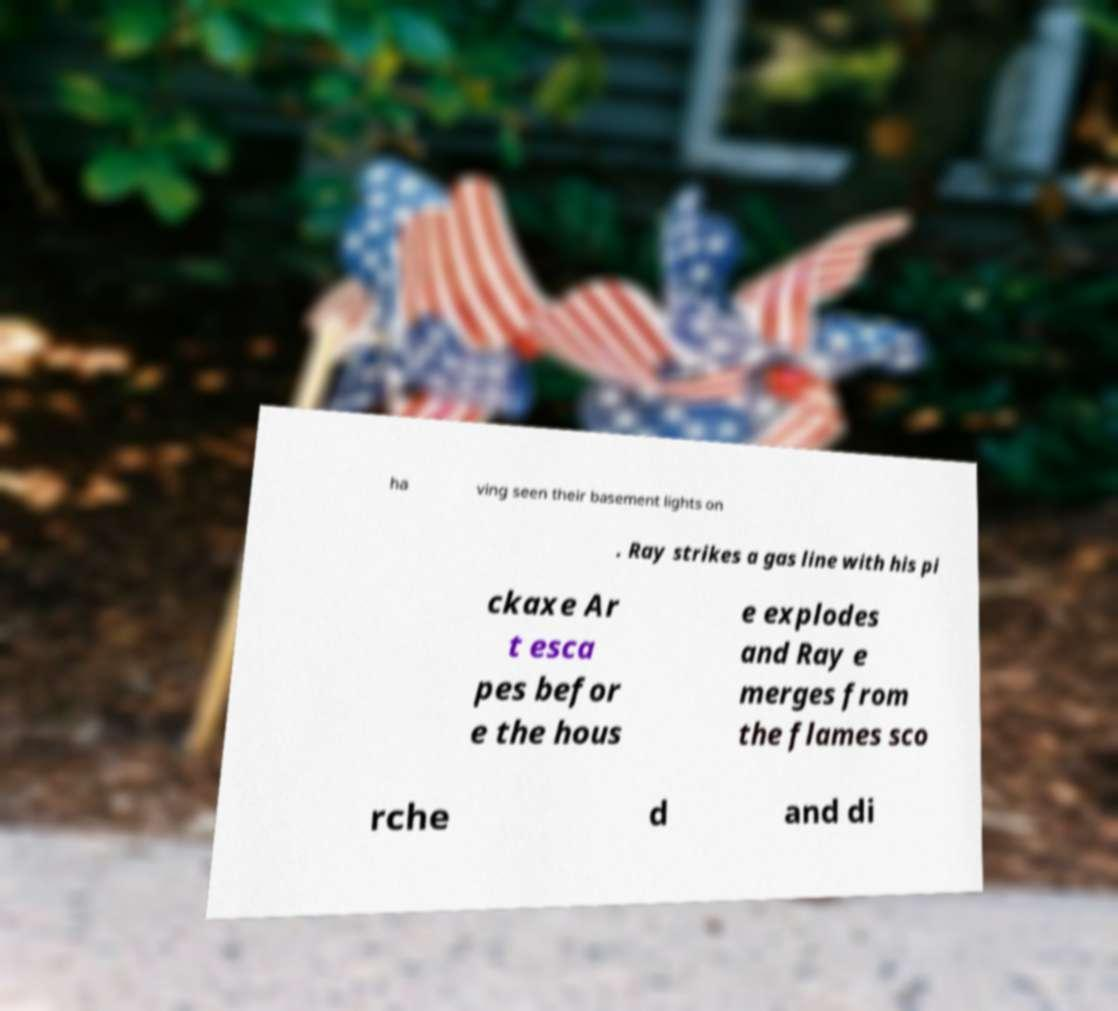Can you accurately transcribe the text from the provided image for me? ha ving seen their basement lights on . Ray strikes a gas line with his pi ckaxe Ar t esca pes befor e the hous e explodes and Ray e merges from the flames sco rche d and di 